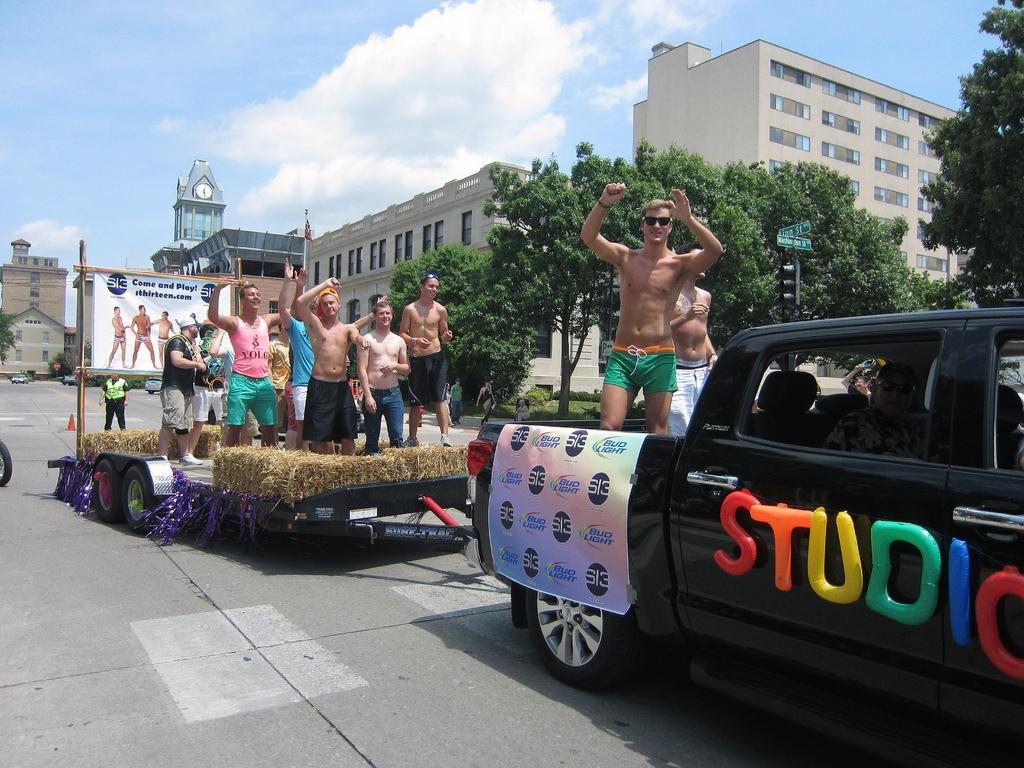What can be seen in the sky in the image? The sky is visible in the image, but no specific details are provided. What type of vegetation is present in the image? There are trees in the image. What type of structures are visible in the image? There are buildings in the image. What time-related object is present in the image? There is a clock in the image. What type of signage is present in the image? There is a banner in the image. What type of living organisms are present in the image? There are people standing in the image. What type of vehicle is present in the image? There is a truck in the image. What type of education is being offered at the truck in the image? There is no indication of education being offered in the image, and the truck is not described as a place of education. 